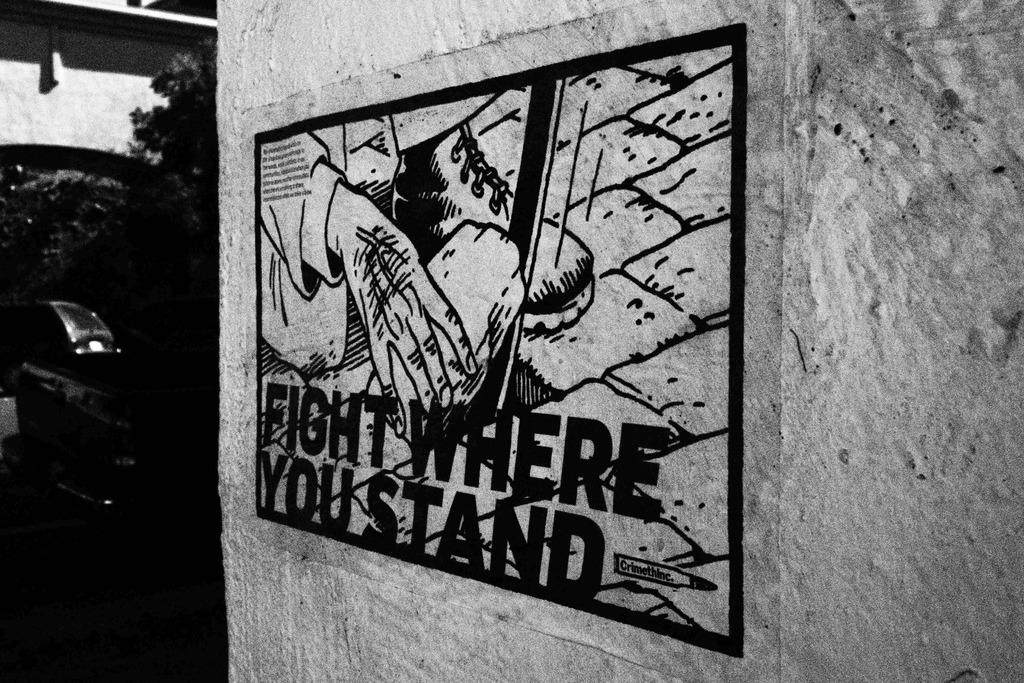What type of artwork is displayed on the wall in the image? There is a black and white picture of a painting on the wall. What else can be seen on the wall besides the artwork? There is text on the wall. What can be seen in the background of the image? There is a group of trees and a building in the background of the image. How does the painting express disgust in the image? The painting does not express any emotions, including disgust, as it is a still image in black and white. 